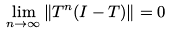<formula> <loc_0><loc_0><loc_500><loc_500>\lim _ { n \to \infty } \| T ^ { n } ( I - T ) \| = 0</formula> 